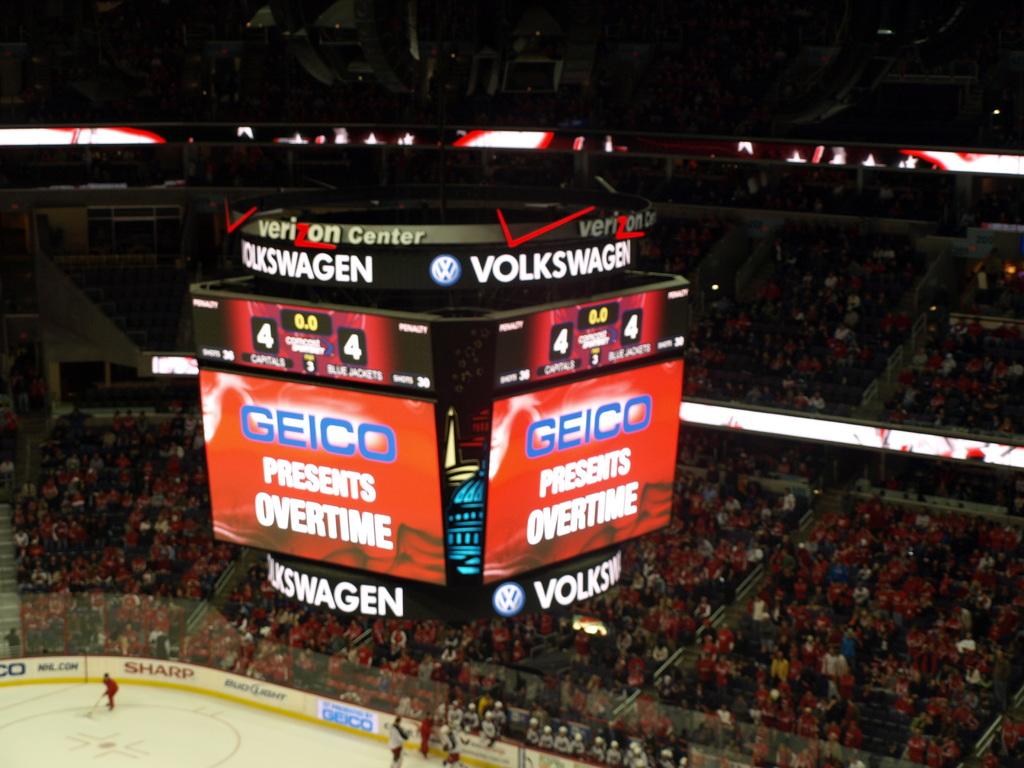Who is a sponsor for the game?
Give a very brief answer. Geico. What is the name of the company written in blue?
Provide a short and direct response. Geico. 